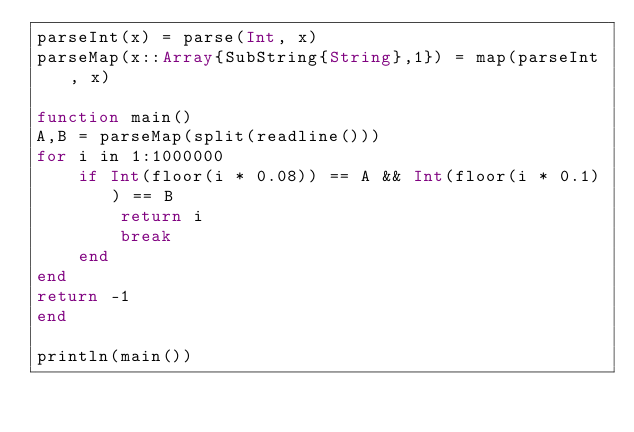<code> <loc_0><loc_0><loc_500><loc_500><_Julia_>parseInt(x) = parse(Int, x)
parseMap(x::Array{SubString{String},1}) = map(parseInt, x)

function main()
A,B = parseMap(split(readline()))    
for i in 1:1000000
    if Int(floor(i * 0.08)) == A && Int(floor(i * 0.1)) == B
        return i
        break
    end
end
return -1
end

println(main())</code> 